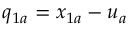<formula> <loc_0><loc_0><loc_500><loc_500>q _ { 1 a } = x _ { 1 a } - u _ { a }</formula> 